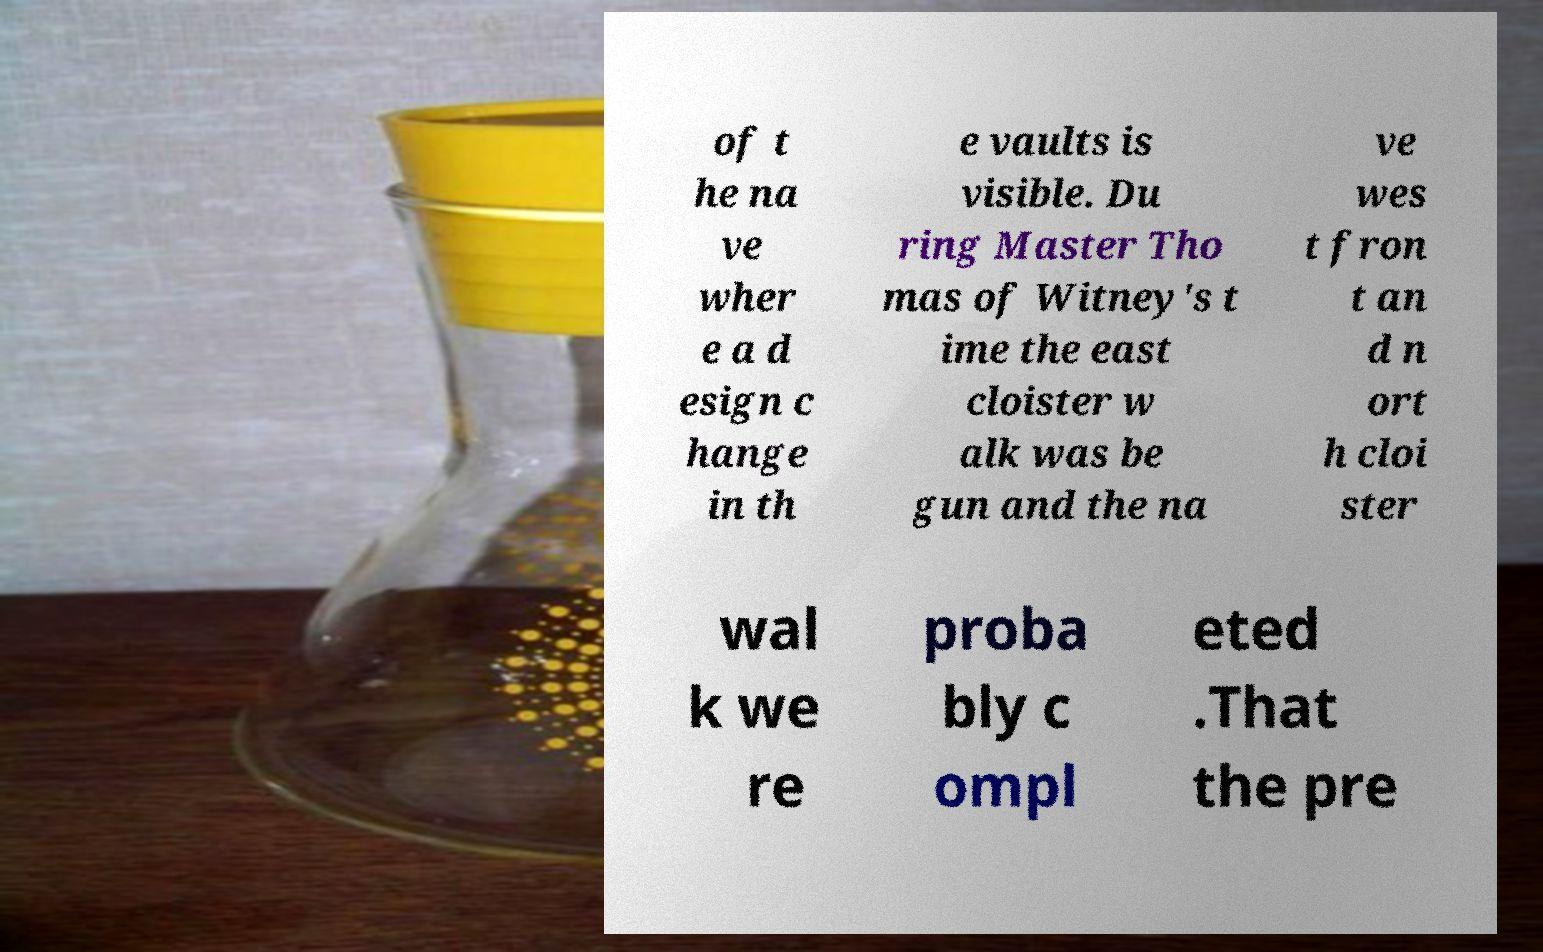I need the written content from this picture converted into text. Can you do that? of t he na ve wher e a d esign c hange in th e vaults is visible. Du ring Master Tho mas of Witney's t ime the east cloister w alk was be gun and the na ve wes t fron t an d n ort h cloi ster wal k we re proba bly c ompl eted .That the pre 